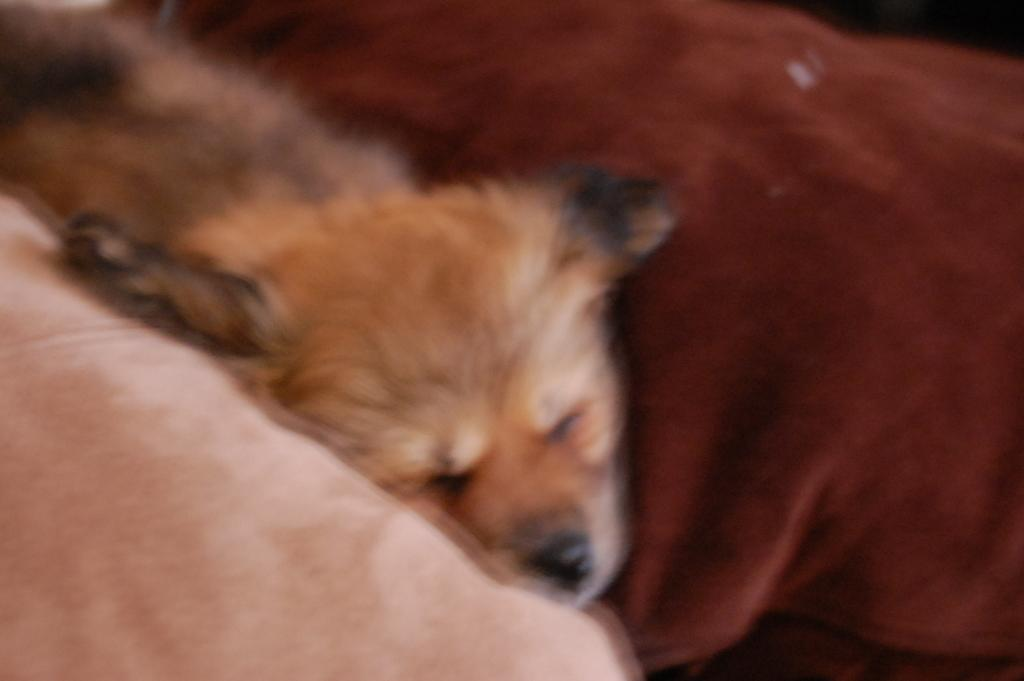What type of animal is present in the image? There is a dog in the image. What is the dog lying on? The dog is lying on a cloth. How much of the cloth can be seen in the image? The cloth is truncated, meaning only a portion of it is visible. What type of insect can be seen crawling on the dog in the image? There is no insect present on the dog in the image. What invention is the dog using to support itself in the image? The dog is lying on a cloth, not using any invention for support. 